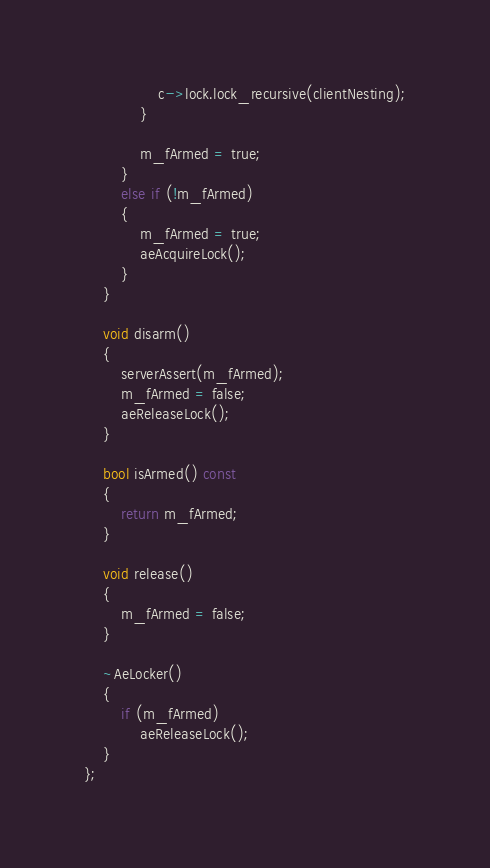Convert code to text. <code><loc_0><loc_0><loc_500><loc_500><_C_>                c->lock.lock_recursive(clientNesting);
            }
            
            m_fArmed = true;
        }
        else if (!m_fArmed)
        {
            m_fArmed = true;
            aeAcquireLock();
        }
    }

    void disarm()
    {
        serverAssert(m_fArmed);
        m_fArmed = false;
        aeReleaseLock();
    }

    bool isArmed() const
    {
        return m_fArmed;
    }

    void release()
    {
        m_fArmed = false;
    }

    ~AeLocker()
    {
        if (m_fArmed)
            aeReleaseLock();
    }
};</code> 